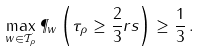<formula> <loc_0><loc_0><loc_500><loc_500>\max _ { w \in \mathcal { T } _ { \rho } } \P _ { w } \left ( \tau _ { \rho } \geq \frac { 2 } { 3 } r s \right ) \geq \frac { 1 } { 3 } \, .</formula> 